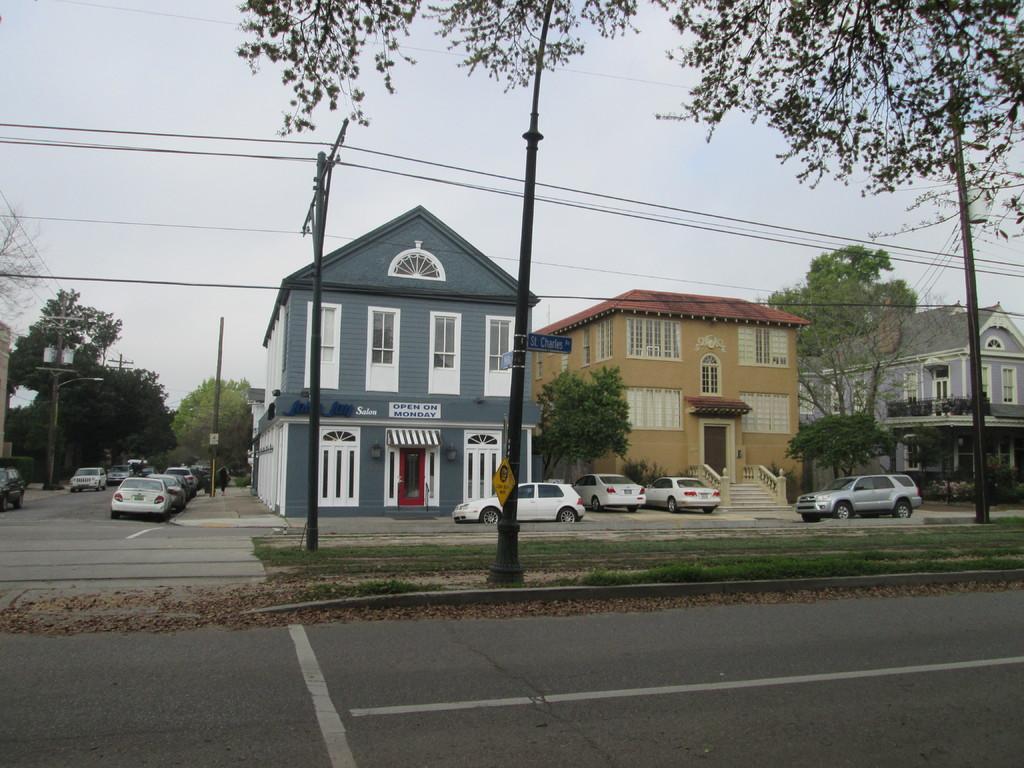In one or two sentences, can you explain what this image depicts? In this picture we can see few poles, sign boards and cars on the road, in the background we can find few trees and houses. 